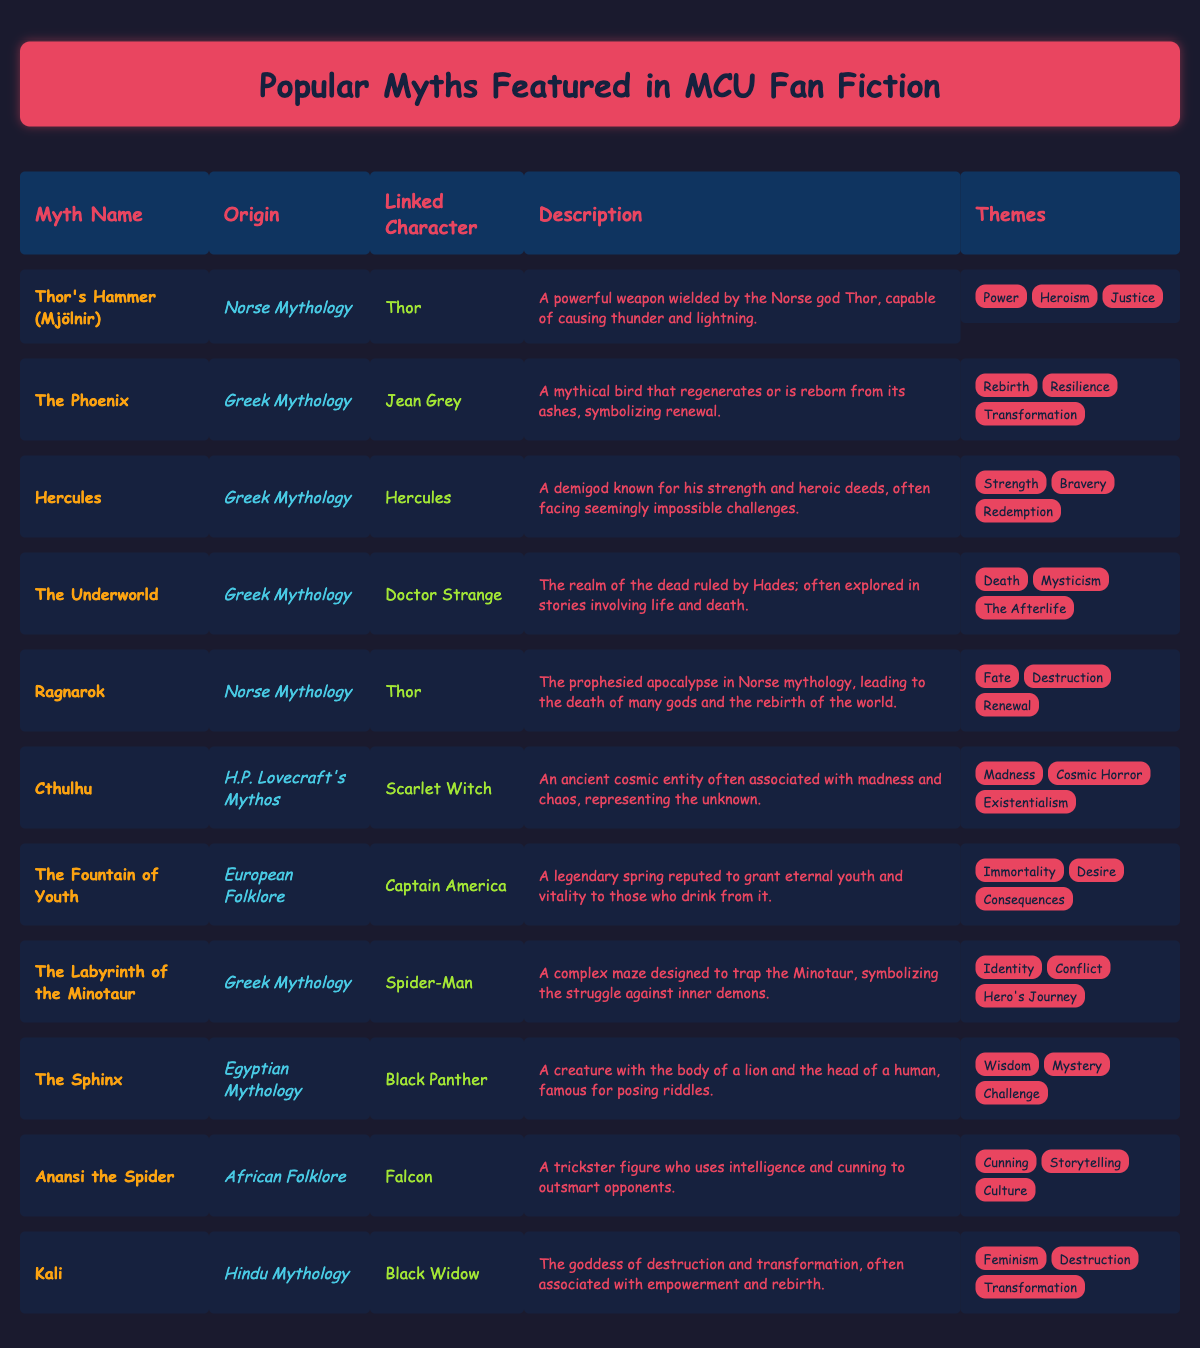What is the myth origin of Thor's Hammer? The table shows that Thor's Hammer is associated with Norse Mythology under the "myth_origin" column.
Answer: Norse Mythology Which character is linked to the myth of The Phoenix? The table indicates that the character linked to The Phoenix is Jean Grey, found in the "linked_character" column.
Answer: Jean Grey How many different themes are associated with Hercules? By reviewing the "themes" column for Hercules, there are three distinct themes listed: Strength, Bravery, and Redemption.
Answer: 3 Is the theme "Resilience" linked to the myth of Thor's Hammer? Looking at the "themes" column for Thor's Hammer, we find "Resilience" is not present, thus the answer is no.
Answer: No Which linked character is associated with the myth of the Sphinx? The table reveals that Black Panther is the character associated with the Sphinx, as noted in the "linked_character" column.
Answer: Black Panther What is the combined total of unique myth origins associated with the linked characters? Upon examining the "myth_origin" column, we find the unique origins are Norse Mythology, Greek Mythology, H.P. Lovecraft's Mythos, European Folklore, Egyptian Mythology, and African Folklore, totaling six distinct origins.
Answer: 6 Is Cthulhu linked to a character from Greek Mythology? By examining the "myth_origin" column for Cthulhu, it is associated with H.P. Lovecraft's Mythos, thus the answer is no.
Answer: No Which myth has the theme of "Destruction" and is linked to a female character? The table indicates that Kali, associated with Hindu Mythology, has the theme of "Destruction", and the linked character is Black Widow.
Answer: Kali What are the descriptions of the myths associated with Thor? The myths linked to Thor are "Thor's Hammer (Mjölnir)" and "Ragnarok". The descriptions for both can be found under the "description" column: Thor's Hammer is described as a powerful weapon capable of causing thunder and lightning, while Ragnarok is described as the prophesied apocalypse leading to the death of many gods and the rebirth of the world.
Answer: Thor's Hammer: A powerful weapon wielded by the Norse god Thor, capable of causing thunder and lightning; Ragnarok: The prophesied apocalypse in Norse mythology, leading to the death of many gods and the rebirth of the world 